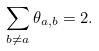Convert formula to latex. <formula><loc_0><loc_0><loc_500><loc_500>\sum _ { b \neq a } \theta _ { a , b } = 2 .</formula> 